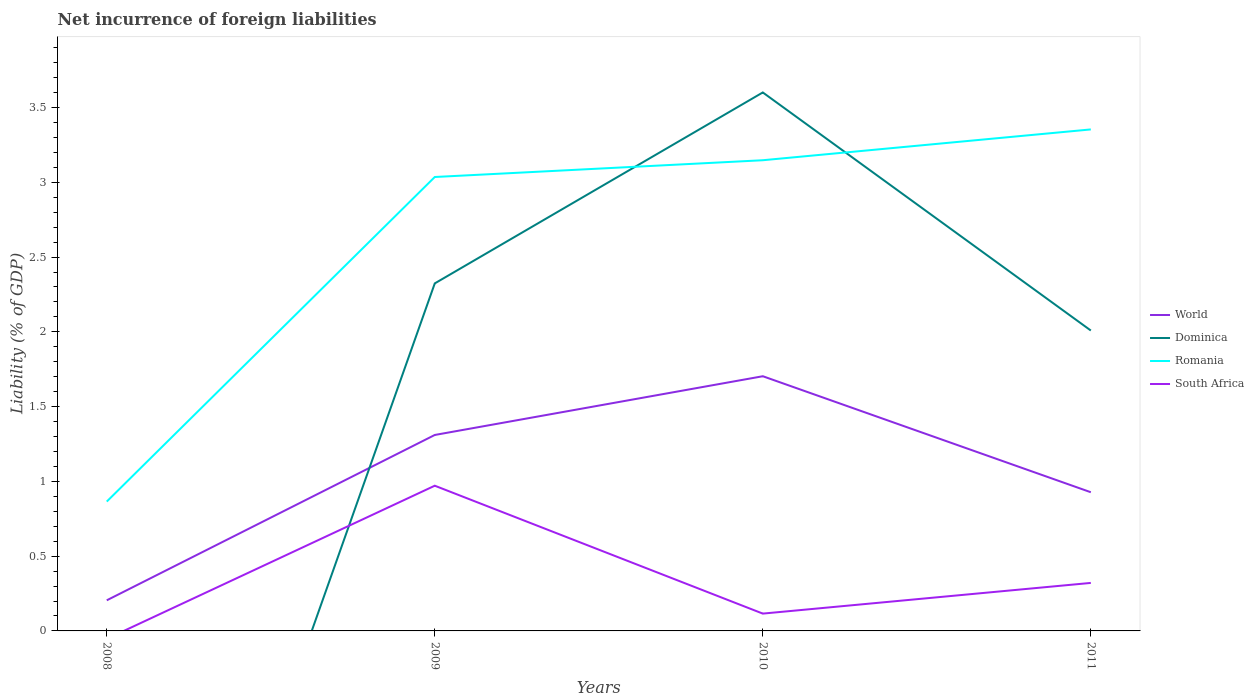Does the line corresponding to Dominica intersect with the line corresponding to Romania?
Offer a terse response. Yes. Is the number of lines equal to the number of legend labels?
Your response must be concise. No. Across all years, what is the maximum net incurrence of foreign liabilities in World?
Make the answer very short. 0.2. What is the total net incurrence of foreign liabilities in World in the graph?
Offer a very short reply. -0.39. What is the difference between the highest and the second highest net incurrence of foreign liabilities in World?
Make the answer very short. 1.5. What is the difference between the highest and the lowest net incurrence of foreign liabilities in Dominica?
Provide a short and direct response. 3. How many years are there in the graph?
Keep it short and to the point. 4. What is the difference between two consecutive major ticks on the Y-axis?
Make the answer very short. 0.5. Are the values on the major ticks of Y-axis written in scientific E-notation?
Provide a succinct answer. No. Does the graph contain any zero values?
Your answer should be compact. Yes. Does the graph contain grids?
Keep it short and to the point. No. Where does the legend appear in the graph?
Your answer should be compact. Center right. How many legend labels are there?
Offer a terse response. 4. How are the legend labels stacked?
Give a very brief answer. Vertical. What is the title of the graph?
Provide a short and direct response. Net incurrence of foreign liabilities. What is the label or title of the Y-axis?
Provide a succinct answer. Liability (% of GDP). What is the Liability (% of GDP) of World in 2008?
Keep it short and to the point. 0.2. What is the Liability (% of GDP) of Dominica in 2008?
Keep it short and to the point. 0. What is the Liability (% of GDP) in Romania in 2008?
Your response must be concise. 0.87. What is the Liability (% of GDP) in World in 2009?
Provide a succinct answer. 1.31. What is the Liability (% of GDP) of Dominica in 2009?
Your answer should be very brief. 2.32. What is the Liability (% of GDP) of Romania in 2009?
Your response must be concise. 3.04. What is the Liability (% of GDP) of South Africa in 2009?
Provide a succinct answer. 0.97. What is the Liability (% of GDP) in World in 2010?
Give a very brief answer. 1.7. What is the Liability (% of GDP) in Dominica in 2010?
Provide a short and direct response. 3.6. What is the Liability (% of GDP) in Romania in 2010?
Ensure brevity in your answer.  3.15. What is the Liability (% of GDP) of South Africa in 2010?
Make the answer very short. 0.12. What is the Liability (% of GDP) of World in 2011?
Keep it short and to the point. 0.93. What is the Liability (% of GDP) in Dominica in 2011?
Make the answer very short. 2.01. What is the Liability (% of GDP) in Romania in 2011?
Keep it short and to the point. 3.35. What is the Liability (% of GDP) of South Africa in 2011?
Provide a short and direct response. 0.32. Across all years, what is the maximum Liability (% of GDP) in World?
Offer a terse response. 1.7. Across all years, what is the maximum Liability (% of GDP) of Dominica?
Your answer should be very brief. 3.6. Across all years, what is the maximum Liability (% of GDP) in Romania?
Your response must be concise. 3.35. Across all years, what is the maximum Liability (% of GDP) in South Africa?
Ensure brevity in your answer.  0.97. Across all years, what is the minimum Liability (% of GDP) in World?
Your answer should be very brief. 0.2. Across all years, what is the minimum Liability (% of GDP) in Dominica?
Provide a short and direct response. 0. Across all years, what is the minimum Liability (% of GDP) of Romania?
Offer a very short reply. 0.87. Across all years, what is the minimum Liability (% of GDP) of South Africa?
Your answer should be very brief. 0. What is the total Liability (% of GDP) in World in the graph?
Your answer should be very brief. 4.15. What is the total Liability (% of GDP) in Dominica in the graph?
Offer a very short reply. 7.93. What is the total Liability (% of GDP) of Romania in the graph?
Ensure brevity in your answer.  10.4. What is the total Liability (% of GDP) in South Africa in the graph?
Ensure brevity in your answer.  1.41. What is the difference between the Liability (% of GDP) in World in 2008 and that in 2009?
Offer a very short reply. -1.11. What is the difference between the Liability (% of GDP) of Romania in 2008 and that in 2009?
Your answer should be compact. -2.17. What is the difference between the Liability (% of GDP) in World in 2008 and that in 2010?
Make the answer very short. -1.5. What is the difference between the Liability (% of GDP) in Romania in 2008 and that in 2010?
Your response must be concise. -2.28. What is the difference between the Liability (% of GDP) of World in 2008 and that in 2011?
Provide a short and direct response. -0.72. What is the difference between the Liability (% of GDP) of Romania in 2008 and that in 2011?
Keep it short and to the point. -2.49. What is the difference between the Liability (% of GDP) of World in 2009 and that in 2010?
Give a very brief answer. -0.39. What is the difference between the Liability (% of GDP) of Dominica in 2009 and that in 2010?
Your response must be concise. -1.28. What is the difference between the Liability (% of GDP) of Romania in 2009 and that in 2010?
Make the answer very short. -0.11. What is the difference between the Liability (% of GDP) in South Africa in 2009 and that in 2010?
Your answer should be compact. 0.86. What is the difference between the Liability (% of GDP) in World in 2009 and that in 2011?
Keep it short and to the point. 0.38. What is the difference between the Liability (% of GDP) of Dominica in 2009 and that in 2011?
Provide a short and direct response. 0.32. What is the difference between the Liability (% of GDP) in Romania in 2009 and that in 2011?
Keep it short and to the point. -0.32. What is the difference between the Liability (% of GDP) in South Africa in 2009 and that in 2011?
Ensure brevity in your answer.  0.65. What is the difference between the Liability (% of GDP) in World in 2010 and that in 2011?
Make the answer very short. 0.78. What is the difference between the Liability (% of GDP) of Dominica in 2010 and that in 2011?
Ensure brevity in your answer.  1.59. What is the difference between the Liability (% of GDP) in Romania in 2010 and that in 2011?
Offer a very short reply. -0.21. What is the difference between the Liability (% of GDP) in South Africa in 2010 and that in 2011?
Keep it short and to the point. -0.21. What is the difference between the Liability (% of GDP) in World in 2008 and the Liability (% of GDP) in Dominica in 2009?
Make the answer very short. -2.12. What is the difference between the Liability (% of GDP) in World in 2008 and the Liability (% of GDP) in Romania in 2009?
Make the answer very short. -2.83. What is the difference between the Liability (% of GDP) in World in 2008 and the Liability (% of GDP) in South Africa in 2009?
Your response must be concise. -0.77. What is the difference between the Liability (% of GDP) in Romania in 2008 and the Liability (% of GDP) in South Africa in 2009?
Give a very brief answer. -0.11. What is the difference between the Liability (% of GDP) in World in 2008 and the Liability (% of GDP) in Dominica in 2010?
Your response must be concise. -3.4. What is the difference between the Liability (% of GDP) in World in 2008 and the Liability (% of GDP) in Romania in 2010?
Offer a very short reply. -2.94. What is the difference between the Liability (% of GDP) in World in 2008 and the Liability (% of GDP) in South Africa in 2010?
Offer a very short reply. 0.09. What is the difference between the Liability (% of GDP) of Romania in 2008 and the Liability (% of GDP) of South Africa in 2010?
Your response must be concise. 0.75. What is the difference between the Liability (% of GDP) in World in 2008 and the Liability (% of GDP) in Dominica in 2011?
Provide a succinct answer. -1.8. What is the difference between the Liability (% of GDP) in World in 2008 and the Liability (% of GDP) in Romania in 2011?
Your response must be concise. -3.15. What is the difference between the Liability (% of GDP) in World in 2008 and the Liability (% of GDP) in South Africa in 2011?
Keep it short and to the point. -0.12. What is the difference between the Liability (% of GDP) in Romania in 2008 and the Liability (% of GDP) in South Africa in 2011?
Provide a succinct answer. 0.54. What is the difference between the Liability (% of GDP) of World in 2009 and the Liability (% of GDP) of Dominica in 2010?
Provide a succinct answer. -2.29. What is the difference between the Liability (% of GDP) in World in 2009 and the Liability (% of GDP) in Romania in 2010?
Ensure brevity in your answer.  -1.84. What is the difference between the Liability (% of GDP) in World in 2009 and the Liability (% of GDP) in South Africa in 2010?
Your response must be concise. 1.19. What is the difference between the Liability (% of GDP) in Dominica in 2009 and the Liability (% of GDP) in Romania in 2010?
Offer a very short reply. -0.82. What is the difference between the Liability (% of GDP) in Dominica in 2009 and the Liability (% of GDP) in South Africa in 2010?
Provide a short and direct response. 2.21. What is the difference between the Liability (% of GDP) in Romania in 2009 and the Liability (% of GDP) in South Africa in 2010?
Ensure brevity in your answer.  2.92. What is the difference between the Liability (% of GDP) in World in 2009 and the Liability (% of GDP) in Dominica in 2011?
Offer a very short reply. -0.7. What is the difference between the Liability (% of GDP) in World in 2009 and the Liability (% of GDP) in Romania in 2011?
Offer a very short reply. -2.04. What is the difference between the Liability (% of GDP) of World in 2009 and the Liability (% of GDP) of South Africa in 2011?
Your answer should be very brief. 0.99. What is the difference between the Liability (% of GDP) in Dominica in 2009 and the Liability (% of GDP) in Romania in 2011?
Your answer should be very brief. -1.03. What is the difference between the Liability (% of GDP) in Dominica in 2009 and the Liability (% of GDP) in South Africa in 2011?
Make the answer very short. 2. What is the difference between the Liability (% of GDP) of Romania in 2009 and the Liability (% of GDP) of South Africa in 2011?
Provide a succinct answer. 2.71. What is the difference between the Liability (% of GDP) of World in 2010 and the Liability (% of GDP) of Dominica in 2011?
Offer a terse response. -0.31. What is the difference between the Liability (% of GDP) of World in 2010 and the Liability (% of GDP) of Romania in 2011?
Your answer should be compact. -1.65. What is the difference between the Liability (% of GDP) of World in 2010 and the Liability (% of GDP) of South Africa in 2011?
Your response must be concise. 1.38. What is the difference between the Liability (% of GDP) of Dominica in 2010 and the Liability (% of GDP) of Romania in 2011?
Your answer should be compact. 0.25. What is the difference between the Liability (% of GDP) in Dominica in 2010 and the Liability (% of GDP) in South Africa in 2011?
Your response must be concise. 3.28. What is the difference between the Liability (% of GDP) in Romania in 2010 and the Liability (% of GDP) in South Africa in 2011?
Give a very brief answer. 2.83. What is the average Liability (% of GDP) in World per year?
Offer a terse response. 1.04. What is the average Liability (% of GDP) of Dominica per year?
Provide a succinct answer. 1.98. What is the average Liability (% of GDP) in Romania per year?
Provide a succinct answer. 2.6. What is the average Liability (% of GDP) of South Africa per year?
Your answer should be compact. 0.35. In the year 2008, what is the difference between the Liability (% of GDP) of World and Liability (% of GDP) of Romania?
Your answer should be very brief. -0.66. In the year 2009, what is the difference between the Liability (% of GDP) in World and Liability (% of GDP) in Dominica?
Your answer should be very brief. -1.01. In the year 2009, what is the difference between the Liability (% of GDP) in World and Liability (% of GDP) in Romania?
Your answer should be compact. -1.73. In the year 2009, what is the difference between the Liability (% of GDP) of World and Liability (% of GDP) of South Africa?
Make the answer very short. 0.34. In the year 2009, what is the difference between the Liability (% of GDP) in Dominica and Liability (% of GDP) in Romania?
Make the answer very short. -0.71. In the year 2009, what is the difference between the Liability (% of GDP) in Dominica and Liability (% of GDP) in South Africa?
Make the answer very short. 1.35. In the year 2009, what is the difference between the Liability (% of GDP) in Romania and Liability (% of GDP) in South Africa?
Ensure brevity in your answer.  2.06. In the year 2010, what is the difference between the Liability (% of GDP) in World and Liability (% of GDP) in Dominica?
Provide a short and direct response. -1.9. In the year 2010, what is the difference between the Liability (% of GDP) of World and Liability (% of GDP) of Romania?
Keep it short and to the point. -1.44. In the year 2010, what is the difference between the Liability (% of GDP) of World and Liability (% of GDP) of South Africa?
Your answer should be compact. 1.59. In the year 2010, what is the difference between the Liability (% of GDP) of Dominica and Liability (% of GDP) of Romania?
Your response must be concise. 0.45. In the year 2010, what is the difference between the Liability (% of GDP) of Dominica and Liability (% of GDP) of South Africa?
Your answer should be compact. 3.49. In the year 2010, what is the difference between the Liability (% of GDP) of Romania and Liability (% of GDP) of South Africa?
Give a very brief answer. 3.03. In the year 2011, what is the difference between the Liability (% of GDP) in World and Liability (% of GDP) in Dominica?
Provide a succinct answer. -1.08. In the year 2011, what is the difference between the Liability (% of GDP) of World and Liability (% of GDP) of Romania?
Keep it short and to the point. -2.43. In the year 2011, what is the difference between the Liability (% of GDP) in World and Liability (% of GDP) in South Africa?
Your response must be concise. 0.61. In the year 2011, what is the difference between the Liability (% of GDP) of Dominica and Liability (% of GDP) of Romania?
Ensure brevity in your answer.  -1.34. In the year 2011, what is the difference between the Liability (% of GDP) of Dominica and Liability (% of GDP) of South Africa?
Make the answer very short. 1.69. In the year 2011, what is the difference between the Liability (% of GDP) of Romania and Liability (% of GDP) of South Africa?
Keep it short and to the point. 3.03. What is the ratio of the Liability (% of GDP) in World in 2008 to that in 2009?
Give a very brief answer. 0.16. What is the ratio of the Liability (% of GDP) in Romania in 2008 to that in 2009?
Offer a terse response. 0.28. What is the ratio of the Liability (% of GDP) of World in 2008 to that in 2010?
Your answer should be compact. 0.12. What is the ratio of the Liability (% of GDP) in Romania in 2008 to that in 2010?
Offer a terse response. 0.27. What is the ratio of the Liability (% of GDP) of World in 2008 to that in 2011?
Make the answer very short. 0.22. What is the ratio of the Liability (% of GDP) in Romania in 2008 to that in 2011?
Your answer should be compact. 0.26. What is the ratio of the Liability (% of GDP) in World in 2009 to that in 2010?
Your response must be concise. 0.77. What is the ratio of the Liability (% of GDP) in Dominica in 2009 to that in 2010?
Make the answer very short. 0.65. What is the ratio of the Liability (% of GDP) in Romania in 2009 to that in 2010?
Provide a short and direct response. 0.96. What is the ratio of the Liability (% of GDP) in South Africa in 2009 to that in 2010?
Provide a short and direct response. 8.39. What is the ratio of the Liability (% of GDP) in World in 2009 to that in 2011?
Your response must be concise. 1.41. What is the ratio of the Liability (% of GDP) in Dominica in 2009 to that in 2011?
Provide a succinct answer. 1.16. What is the ratio of the Liability (% of GDP) in Romania in 2009 to that in 2011?
Your answer should be very brief. 0.91. What is the ratio of the Liability (% of GDP) in South Africa in 2009 to that in 2011?
Provide a succinct answer. 3.02. What is the ratio of the Liability (% of GDP) of World in 2010 to that in 2011?
Your answer should be very brief. 1.84. What is the ratio of the Liability (% of GDP) in Dominica in 2010 to that in 2011?
Your answer should be compact. 1.79. What is the ratio of the Liability (% of GDP) of Romania in 2010 to that in 2011?
Keep it short and to the point. 0.94. What is the ratio of the Liability (% of GDP) of South Africa in 2010 to that in 2011?
Your response must be concise. 0.36. What is the difference between the highest and the second highest Liability (% of GDP) in World?
Offer a very short reply. 0.39. What is the difference between the highest and the second highest Liability (% of GDP) in Dominica?
Make the answer very short. 1.28. What is the difference between the highest and the second highest Liability (% of GDP) of Romania?
Ensure brevity in your answer.  0.21. What is the difference between the highest and the second highest Liability (% of GDP) of South Africa?
Offer a terse response. 0.65. What is the difference between the highest and the lowest Liability (% of GDP) in World?
Your answer should be compact. 1.5. What is the difference between the highest and the lowest Liability (% of GDP) of Dominica?
Make the answer very short. 3.6. What is the difference between the highest and the lowest Liability (% of GDP) in Romania?
Your answer should be very brief. 2.49. What is the difference between the highest and the lowest Liability (% of GDP) in South Africa?
Give a very brief answer. 0.97. 